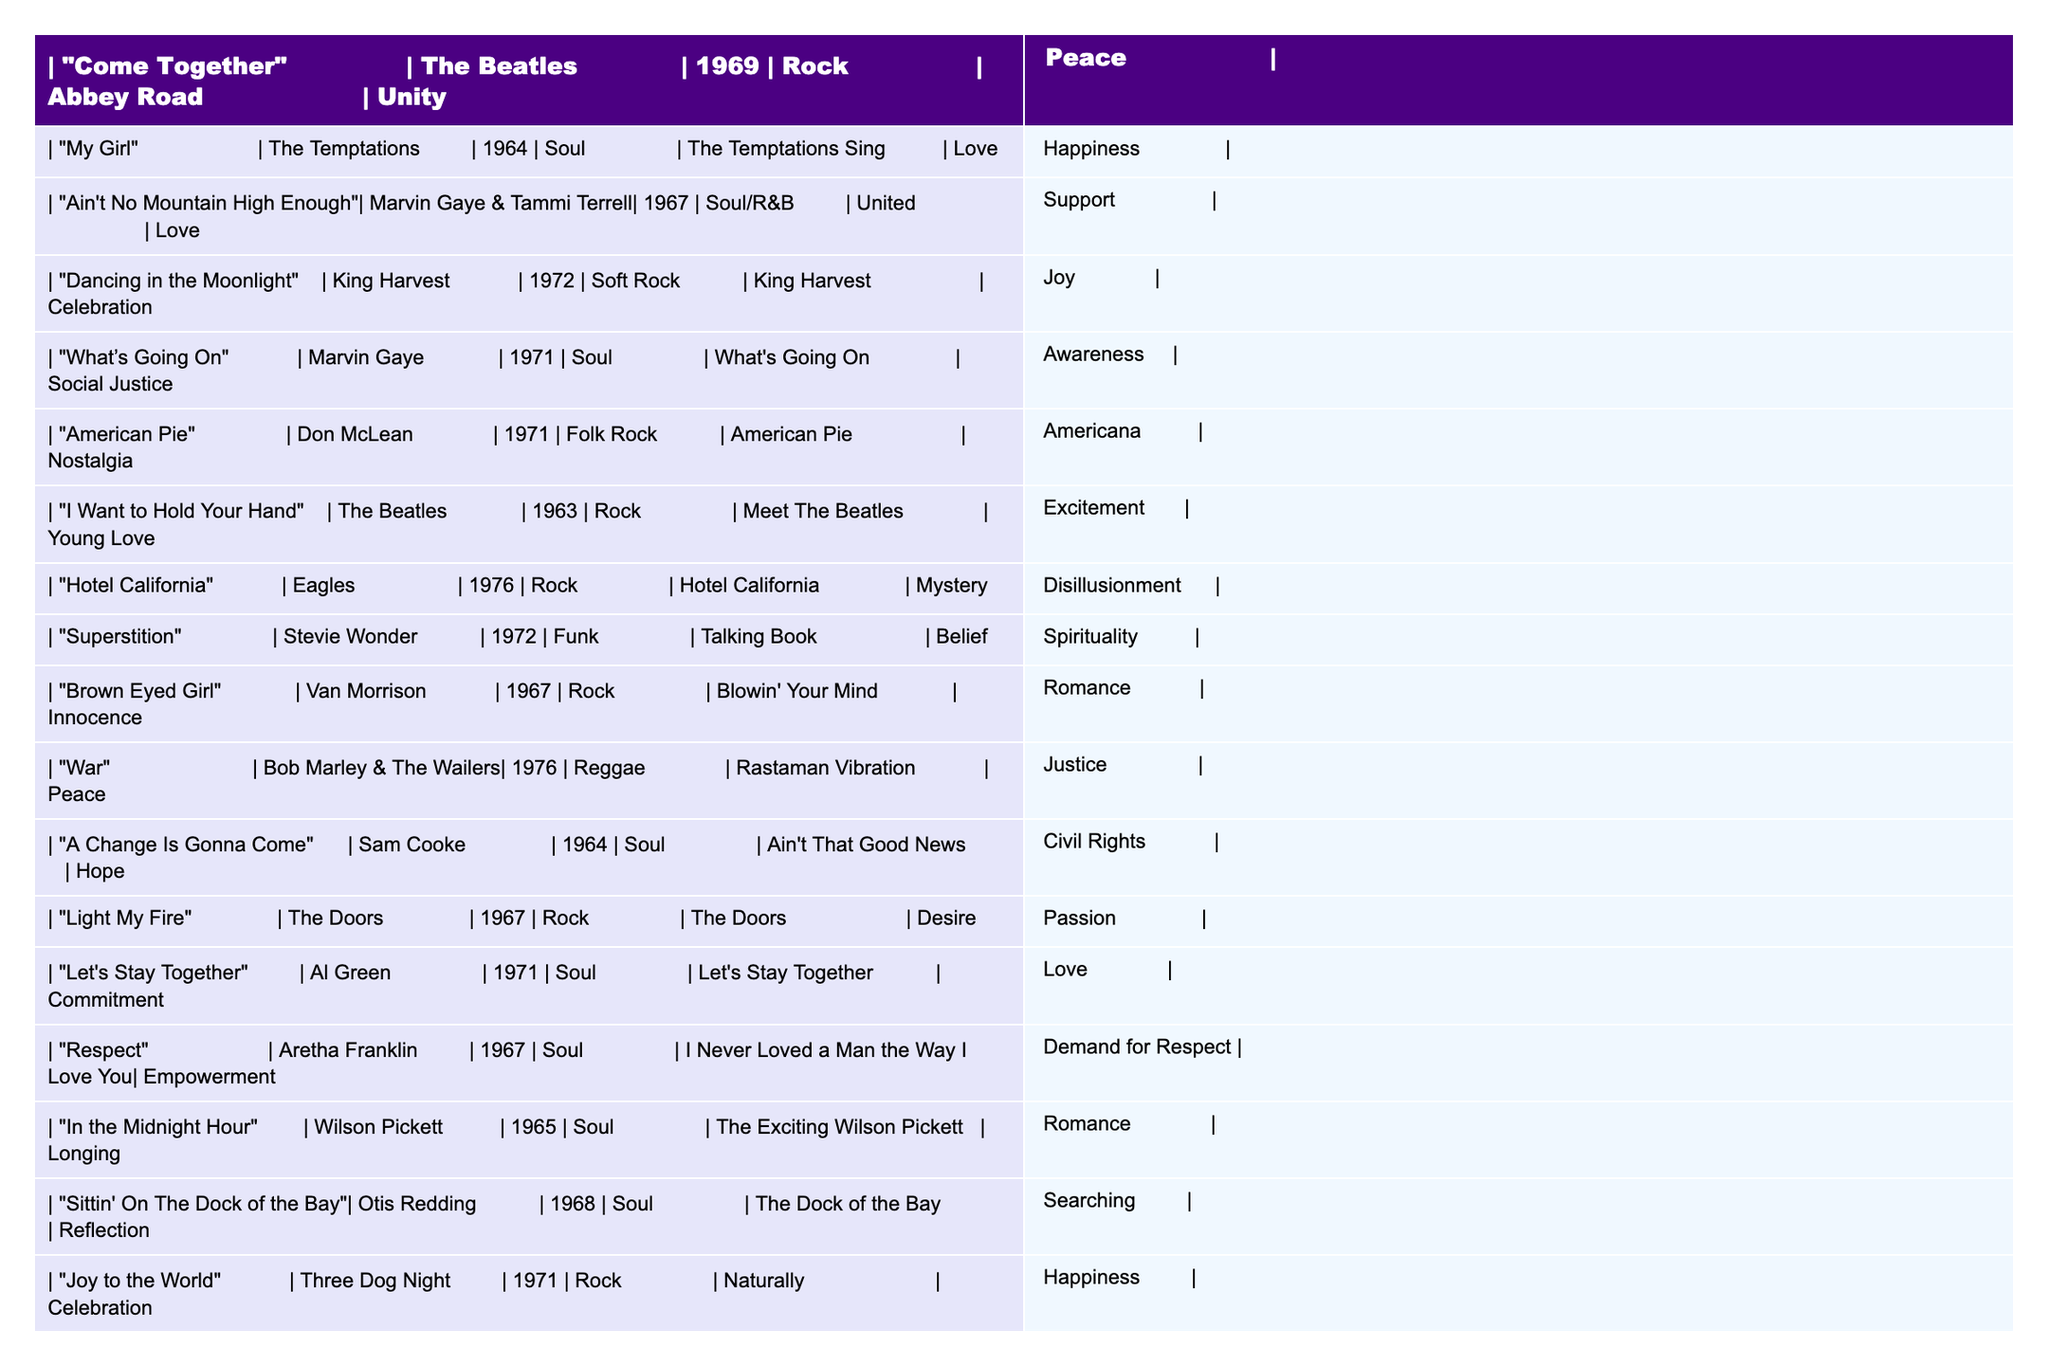What's the title of the song by The Beatles that was released in 1963? The title of the song is "I Want to Hold Your Hand." I look for the artist's name, which is The Beatles, and then I find the corresponding year. The only song listed under The Beatles for 1963 is "I Want to Hold Your Hand."
Answer: "I Want to Hold Your Hand" Which song from 1971 is associated with social justice? "What's Going On" is the song that addresses social justice themes. I check the songs listed under the year 1971 and identify the themes, with "What's Going On" specifically categorized under social justice and awareness.
Answer: "What's Going On" Who performed the song "Brown Eyed Girl"? The artist for "Brown Eyed Girl" is Van Morrison. I locate the row for "Brown Eyed Girl" and find the artist listed beside the title.
Answer: Van Morrison How many songs in the table are categorized as "Rock"? There are 7 songs categorized as "Rock." I review each entry and count them: "Come Together," "I Want to Hold Your Hand," "Hotel California," "Light My Fire," "Joy to the World," "For What It's Worth," and "Dancing in the Moonlight."
Answer: 7 Is "A Change Is Gonna Come" a song about hope? Yes, "A Change Is Gonna Come" is about hope. I look at the song title and find that it is associated with the theme of hope and civil rights.
Answer: Yes Which song by Marvin Gaye relates to love and support? "Ain't No Mountain High Enough" by Marvin Gaye & Tammi Terrell is related to love and support. I search for Marvin Gaye in the table and identify the song that corresponds to the themes mentioned.
Answer: "Ain't No Mountain High Enough" Name the song released in 1972 that promotes celebration and joy. The song is "Dancing in the Moonlight." I check the year 1972 and find that "Dancing in the Moonlight" is associated with celebration and joy.
Answer: "Dancing in the Moonlight" Identify the song with the theme of empowerment that was released in 1967. The song is "Respect" by Aretha Franklin. I look for the year 1967 in the table and find "Respect" matches with the empowerment theme.
Answer: "Respect" Which song from the table has the title associated with a geographical feature? "Sittin' On The Dock of the Bay" is associated with a geographical feature, 'dock.' I scan through the titles and find this song specifically refers to a place.
Answer: "Sittin' On The Dock of the Bay" How many songs focus on themes of love from the Soul genre? There are 5 songs focused on love from the Soul genre: "My Girl," "Ain't No Mountain High Enough," "Let's Stay Together," "A Change Is Gonna Come," and "Respect." I identify and count them in the Soul genre.
Answer: 5 